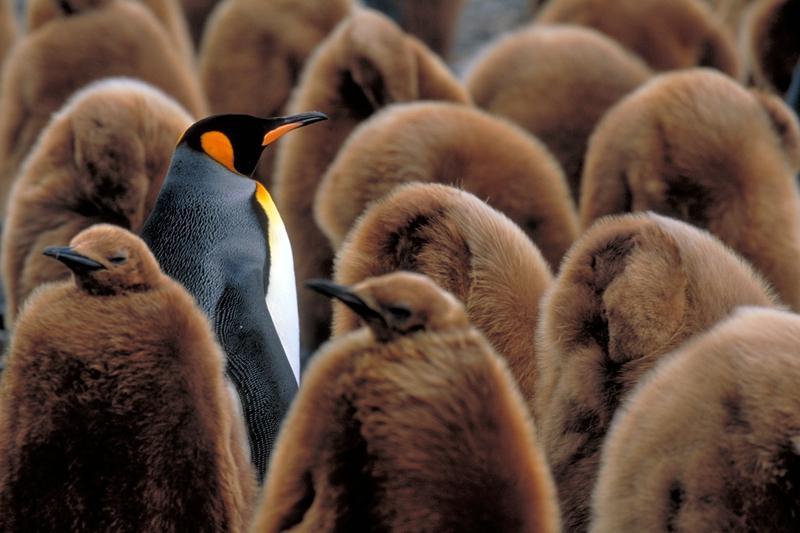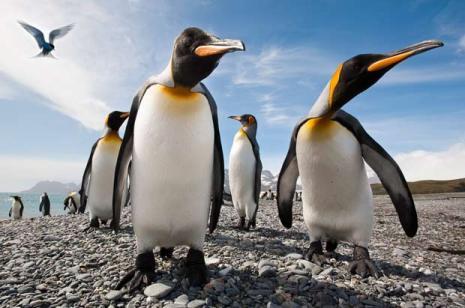The first image is the image on the left, the second image is the image on the right. Considering the images on both sides, is "There is at least one brown furry penguin." valid? Answer yes or no. Yes. The first image is the image on the left, the second image is the image on the right. For the images shown, is this caption "An image includes multiple penguins with fuzzy brown feathers, along with at least one black and white penguin." true? Answer yes or no. Yes. 